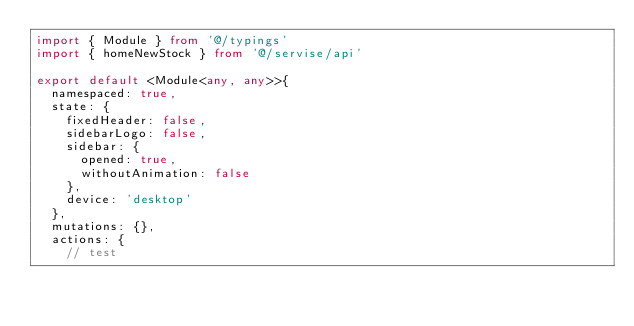Convert code to text. <code><loc_0><loc_0><loc_500><loc_500><_TypeScript_>import { Module } from '@/typings'
import { homeNewStock } from '@/servise/api'

export default <Module<any, any>>{
	namespaced: true,
	state: {
		fixedHeader: false,
		sidebarLogo: false,
		sidebar: {
			opened: true,
			withoutAnimation: false
		},
		device: 'desktop'
	},
	mutations: {},
	actions: {
		// test</code> 